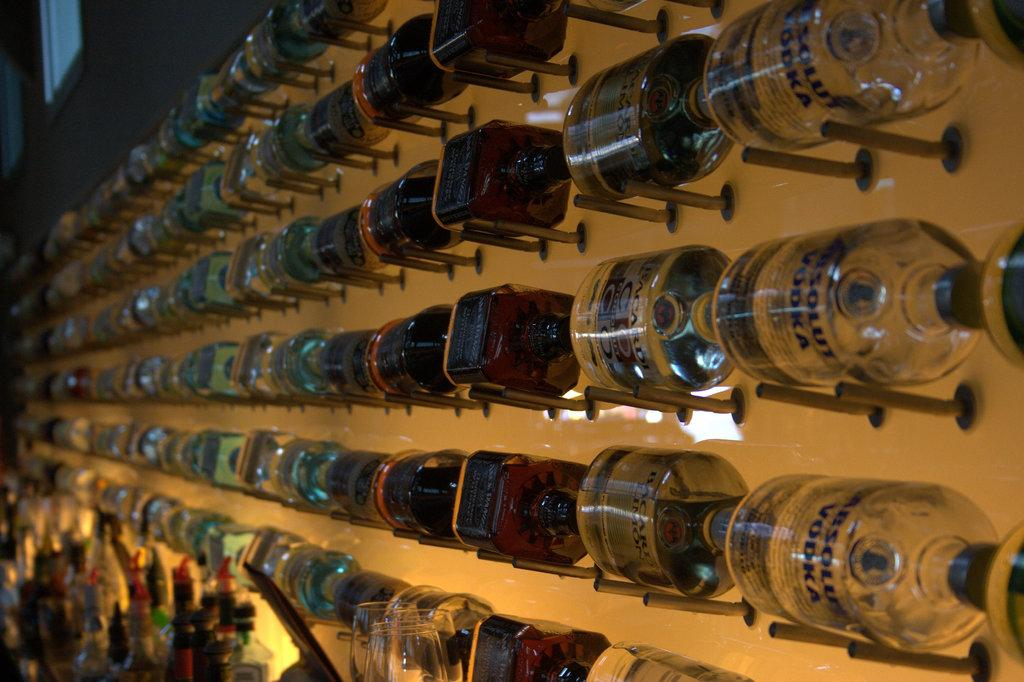What objects are present in the image? There are multiple bottles in the image. How are the bottles arranged in the image? The bottles are arranged in a sequence. What type of haircut is visible on the drawer in the image? There is no drawer or haircut present in the image; it only features multiple bottles arranged in a sequence. 